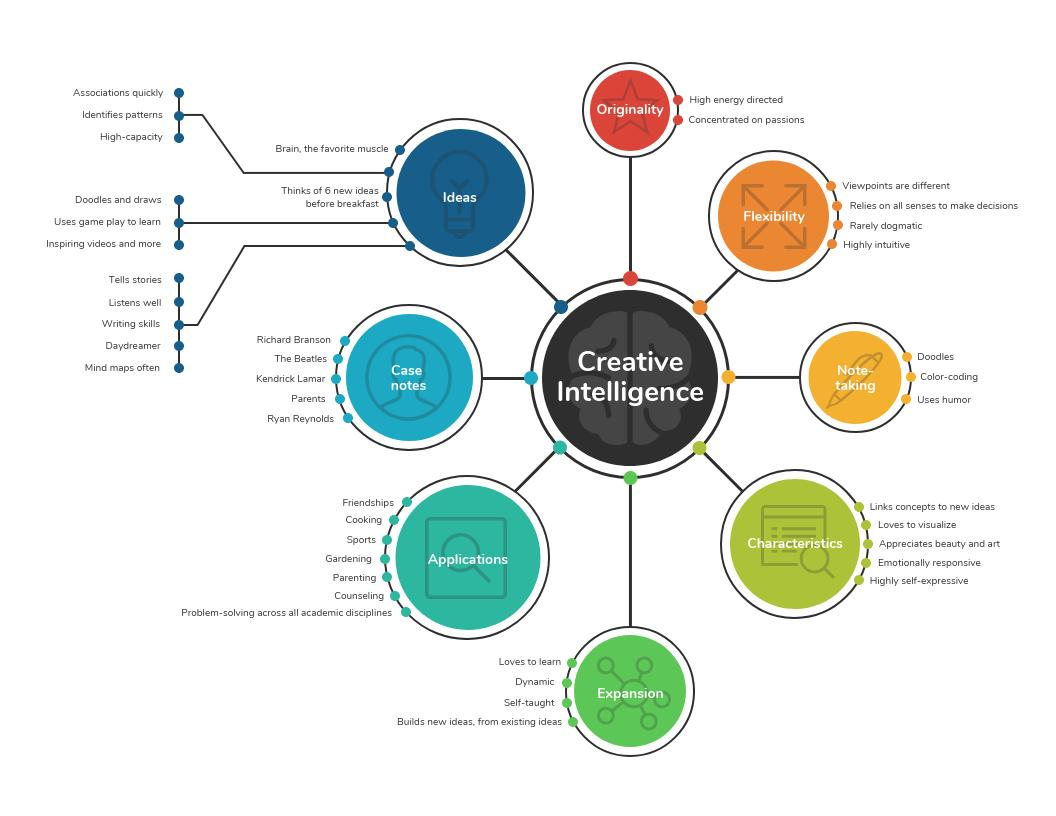Highlight a few significant elements in this photo. The color of the circle in which the word "Originality" is written is red. 